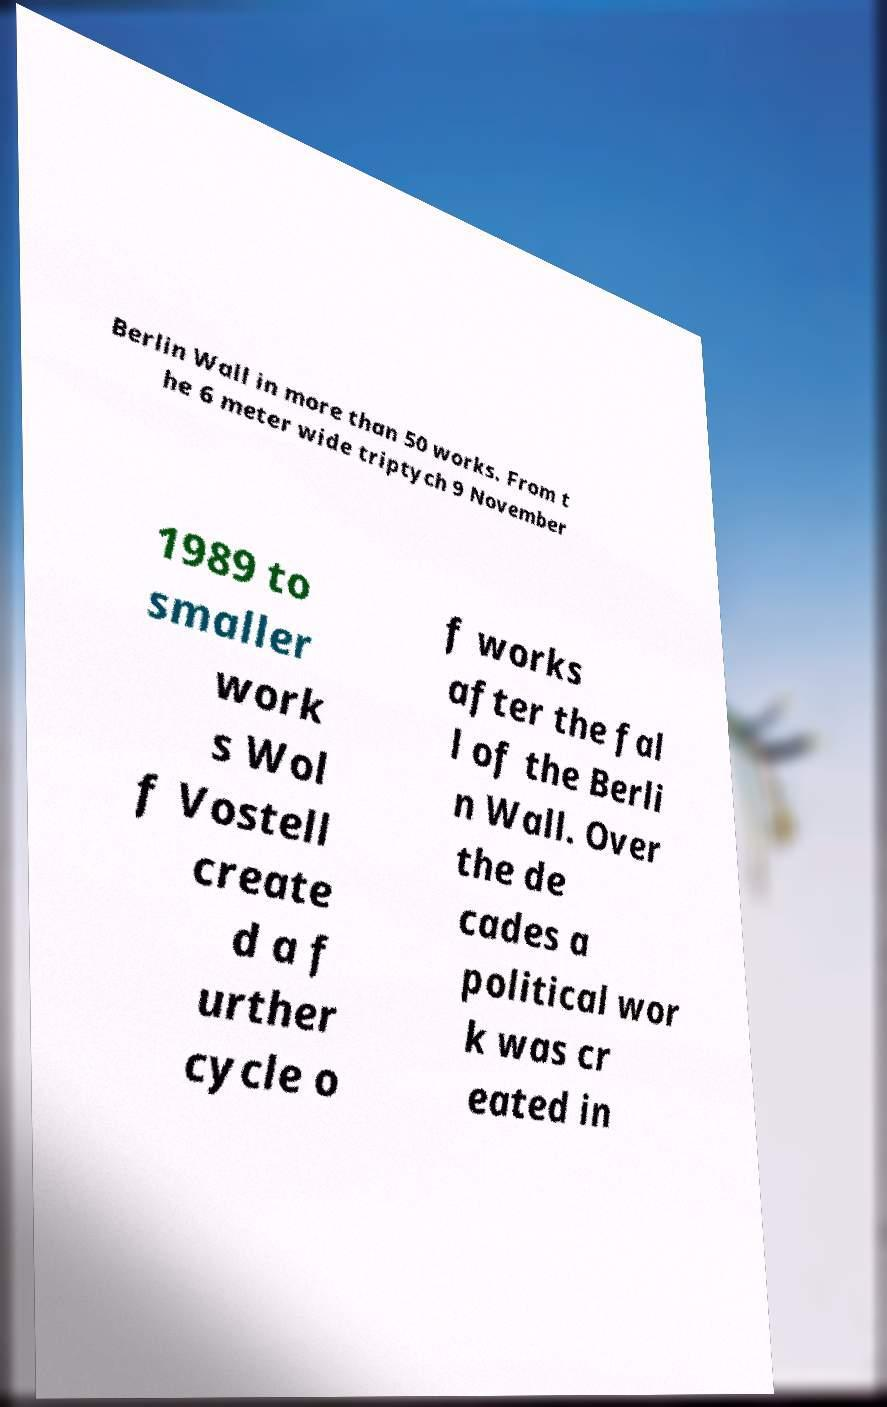Can you accurately transcribe the text from the provided image for me? Berlin Wall in more than 50 works. From t he 6 meter wide triptych 9 November 1989 to smaller work s Wol f Vostell create d a f urther cycle o f works after the fal l of the Berli n Wall. Over the de cades a political wor k was cr eated in 